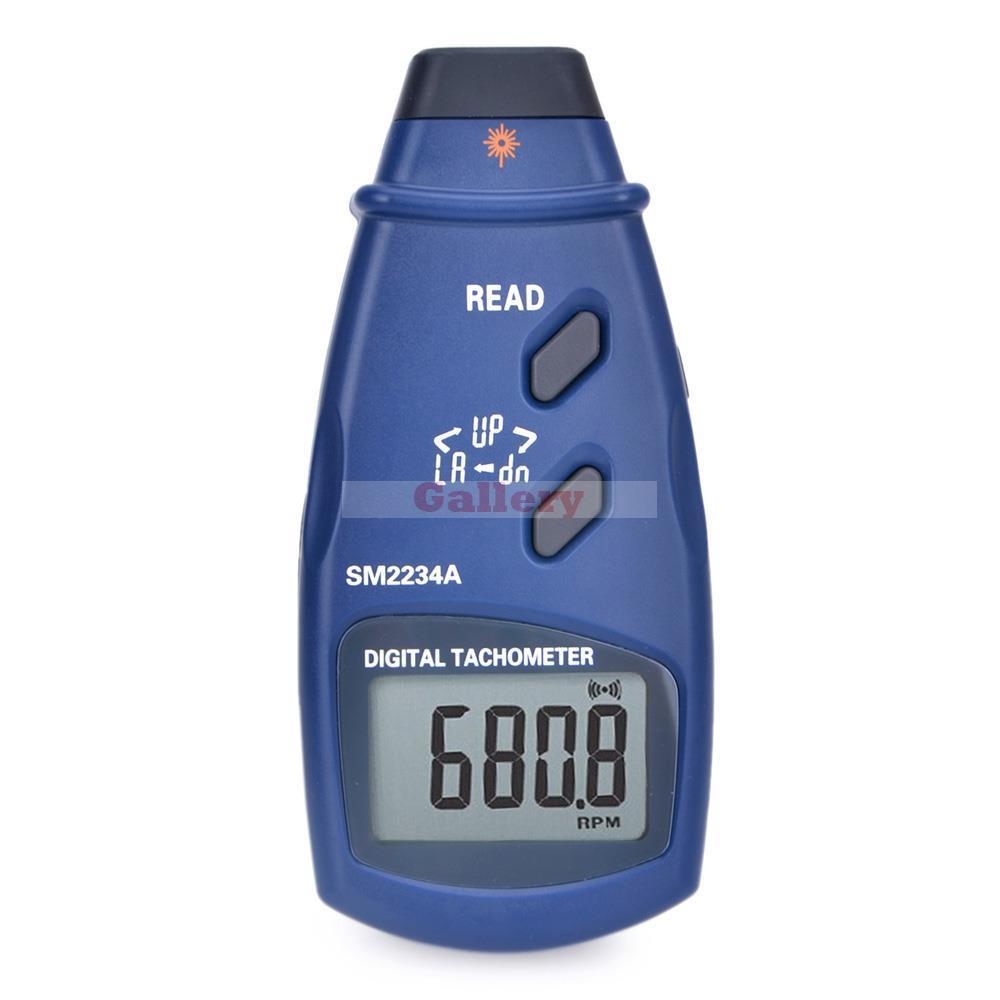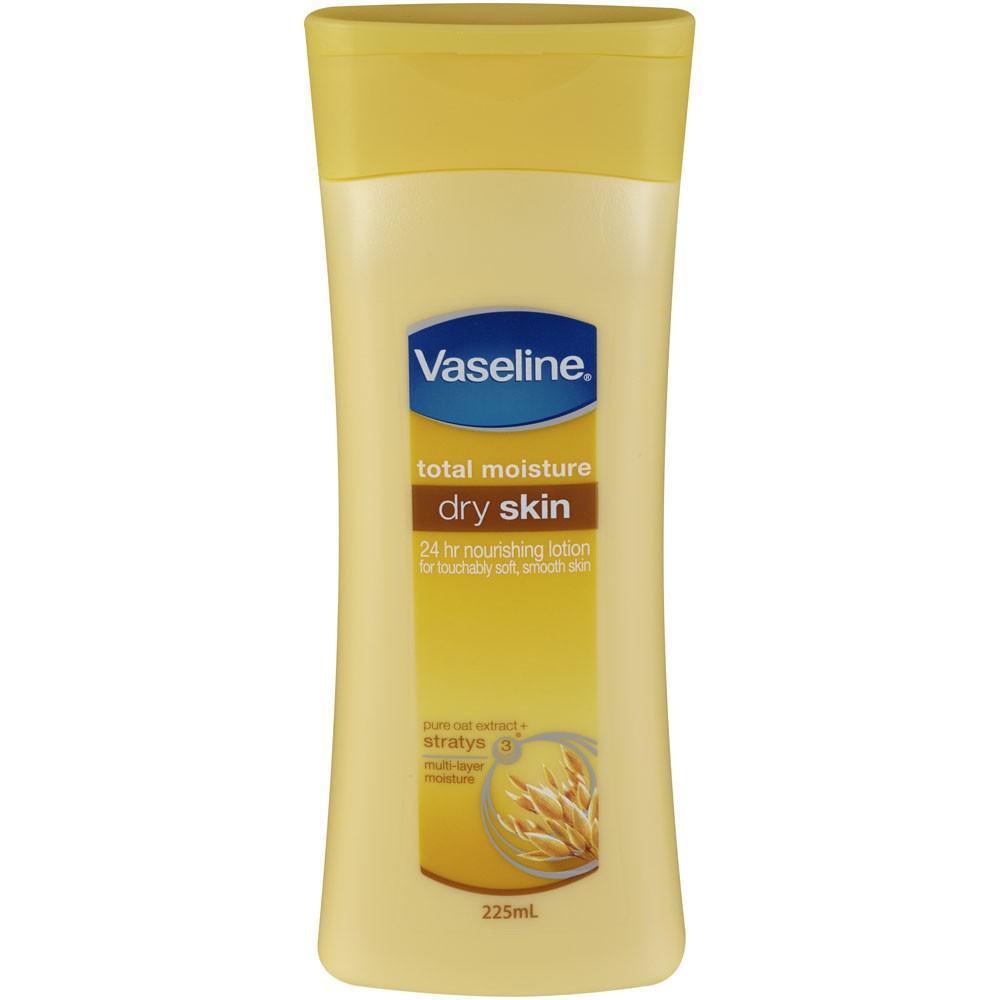The first image is the image on the left, the second image is the image on the right. Evaluate the accuracy of this statement regarding the images: "There are two yellow bottles of lotion". Is it true? Answer yes or no. No. 